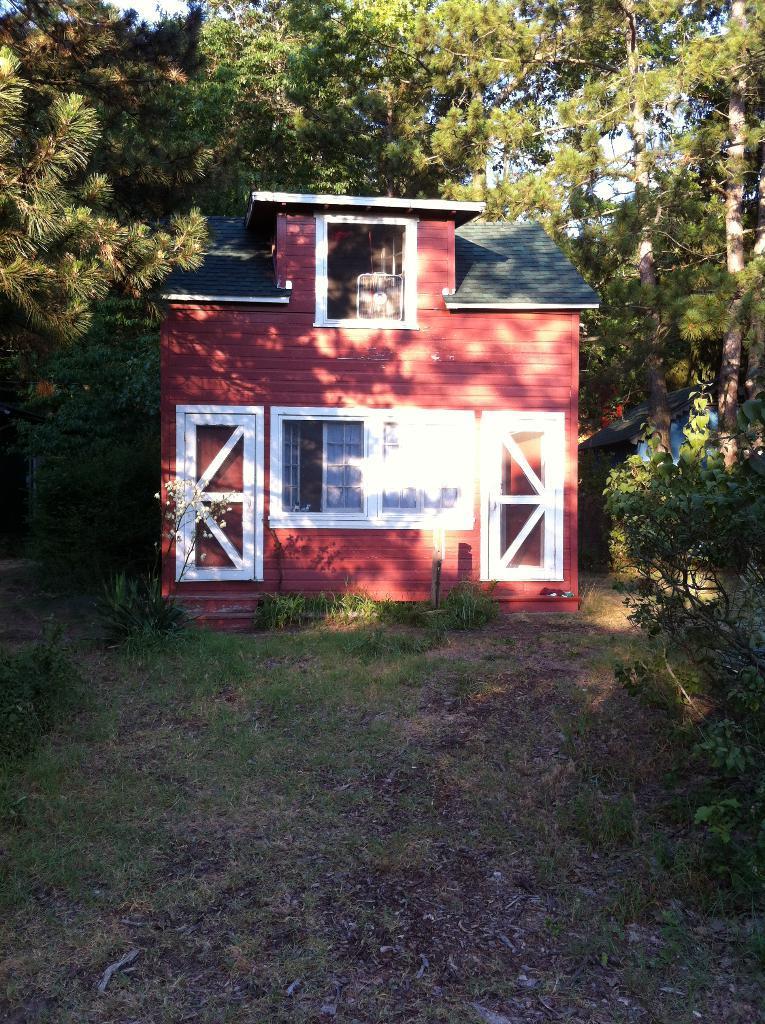How would you summarize this image in a sentence or two? At the bottom we can see grass and leaves on the ground. In the middle there is a house,windows and doors. In the background there are trees,houses and sky. 